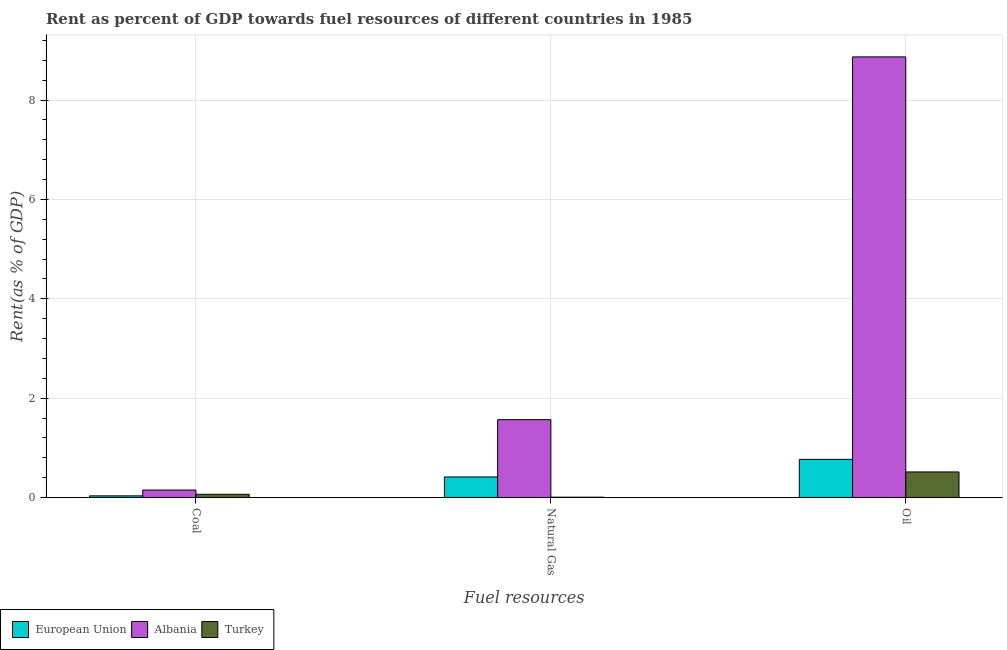How many groups of bars are there?
Offer a very short reply. 3. Are the number of bars per tick equal to the number of legend labels?
Your response must be concise. Yes. Are the number of bars on each tick of the X-axis equal?
Offer a very short reply. Yes. How many bars are there on the 3rd tick from the left?
Give a very brief answer. 3. What is the label of the 3rd group of bars from the left?
Provide a short and direct response. Oil. What is the rent towards coal in Albania?
Keep it short and to the point. 0.15. Across all countries, what is the maximum rent towards coal?
Your answer should be very brief. 0.15. Across all countries, what is the minimum rent towards oil?
Offer a terse response. 0.51. In which country was the rent towards natural gas maximum?
Offer a terse response. Albania. In which country was the rent towards natural gas minimum?
Your answer should be very brief. Turkey. What is the total rent towards natural gas in the graph?
Offer a terse response. 1.99. What is the difference between the rent towards oil in Albania and that in Turkey?
Give a very brief answer. 8.35. What is the difference between the rent towards natural gas in Albania and the rent towards oil in European Union?
Provide a succinct answer. 0.8. What is the average rent towards coal per country?
Offer a terse response. 0.08. What is the difference between the rent towards coal and rent towards oil in Turkey?
Provide a succinct answer. -0.45. In how many countries, is the rent towards coal greater than 8.4 %?
Offer a terse response. 0. What is the ratio of the rent towards oil in Albania to that in Turkey?
Your answer should be compact. 17.25. What is the difference between the highest and the second highest rent towards oil?
Offer a terse response. 8.1. What is the difference between the highest and the lowest rent towards oil?
Provide a succinct answer. 8.35. In how many countries, is the rent towards coal greater than the average rent towards coal taken over all countries?
Your answer should be compact. 1. What does the 1st bar from the left in Coal represents?
Your response must be concise. European Union. Is it the case that in every country, the sum of the rent towards coal and rent towards natural gas is greater than the rent towards oil?
Give a very brief answer. No. How many bars are there?
Provide a short and direct response. 9. Are all the bars in the graph horizontal?
Your answer should be very brief. No. Does the graph contain any zero values?
Provide a short and direct response. No. Does the graph contain grids?
Your response must be concise. Yes. Where does the legend appear in the graph?
Keep it short and to the point. Bottom left. How are the legend labels stacked?
Your answer should be very brief. Horizontal. What is the title of the graph?
Make the answer very short. Rent as percent of GDP towards fuel resources of different countries in 1985. Does "Congo (Republic)" appear as one of the legend labels in the graph?
Ensure brevity in your answer.  No. What is the label or title of the X-axis?
Make the answer very short. Fuel resources. What is the label or title of the Y-axis?
Give a very brief answer. Rent(as % of GDP). What is the Rent(as % of GDP) of European Union in Coal?
Keep it short and to the point. 0.03. What is the Rent(as % of GDP) in Albania in Coal?
Your answer should be compact. 0.15. What is the Rent(as % of GDP) of Turkey in Coal?
Your response must be concise. 0.06. What is the Rent(as % of GDP) of European Union in Natural Gas?
Your response must be concise. 0.41. What is the Rent(as % of GDP) of Albania in Natural Gas?
Your response must be concise. 1.57. What is the Rent(as % of GDP) in Turkey in Natural Gas?
Keep it short and to the point. 0.01. What is the Rent(as % of GDP) of European Union in Oil?
Offer a very short reply. 0.77. What is the Rent(as % of GDP) in Albania in Oil?
Your answer should be compact. 8.87. What is the Rent(as % of GDP) of Turkey in Oil?
Provide a short and direct response. 0.51. Across all Fuel resources, what is the maximum Rent(as % of GDP) in European Union?
Your answer should be compact. 0.77. Across all Fuel resources, what is the maximum Rent(as % of GDP) in Albania?
Provide a succinct answer. 8.87. Across all Fuel resources, what is the maximum Rent(as % of GDP) in Turkey?
Provide a short and direct response. 0.51. Across all Fuel resources, what is the minimum Rent(as % of GDP) of European Union?
Your response must be concise. 0.03. Across all Fuel resources, what is the minimum Rent(as % of GDP) in Albania?
Your response must be concise. 0.15. Across all Fuel resources, what is the minimum Rent(as % of GDP) of Turkey?
Ensure brevity in your answer.  0.01. What is the total Rent(as % of GDP) of European Union in the graph?
Your answer should be compact. 1.21. What is the total Rent(as % of GDP) of Albania in the graph?
Offer a very short reply. 10.59. What is the total Rent(as % of GDP) of Turkey in the graph?
Give a very brief answer. 0.59. What is the difference between the Rent(as % of GDP) in European Union in Coal and that in Natural Gas?
Provide a short and direct response. -0.38. What is the difference between the Rent(as % of GDP) of Albania in Coal and that in Natural Gas?
Offer a terse response. -1.42. What is the difference between the Rent(as % of GDP) of Turkey in Coal and that in Natural Gas?
Offer a very short reply. 0.06. What is the difference between the Rent(as % of GDP) in European Union in Coal and that in Oil?
Your answer should be compact. -0.73. What is the difference between the Rent(as % of GDP) in Albania in Coal and that in Oil?
Provide a short and direct response. -8.72. What is the difference between the Rent(as % of GDP) in Turkey in Coal and that in Oil?
Your response must be concise. -0.45. What is the difference between the Rent(as % of GDP) in European Union in Natural Gas and that in Oil?
Make the answer very short. -0.35. What is the difference between the Rent(as % of GDP) in Albania in Natural Gas and that in Oil?
Your answer should be compact. -7.3. What is the difference between the Rent(as % of GDP) of Turkey in Natural Gas and that in Oil?
Offer a terse response. -0.51. What is the difference between the Rent(as % of GDP) in European Union in Coal and the Rent(as % of GDP) in Albania in Natural Gas?
Your answer should be compact. -1.53. What is the difference between the Rent(as % of GDP) in European Union in Coal and the Rent(as % of GDP) in Turkey in Natural Gas?
Your answer should be very brief. 0.03. What is the difference between the Rent(as % of GDP) in Albania in Coal and the Rent(as % of GDP) in Turkey in Natural Gas?
Keep it short and to the point. 0.14. What is the difference between the Rent(as % of GDP) of European Union in Coal and the Rent(as % of GDP) of Albania in Oil?
Provide a succinct answer. -8.84. What is the difference between the Rent(as % of GDP) in European Union in Coal and the Rent(as % of GDP) in Turkey in Oil?
Ensure brevity in your answer.  -0.48. What is the difference between the Rent(as % of GDP) of Albania in Coal and the Rent(as % of GDP) of Turkey in Oil?
Give a very brief answer. -0.36. What is the difference between the Rent(as % of GDP) in European Union in Natural Gas and the Rent(as % of GDP) in Albania in Oil?
Ensure brevity in your answer.  -8.46. What is the difference between the Rent(as % of GDP) of European Union in Natural Gas and the Rent(as % of GDP) of Turkey in Oil?
Ensure brevity in your answer.  -0.1. What is the difference between the Rent(as % of GDP) of Albania in Natural Gas and the Rent(as % of GDP) of Turkey in Oil?
Your answer should be very brief. 1.05. What is the average Rent(as % of GDP) of European Union per Fuel resources?
Give a very brief answer. 0.4. What is the average Rent(as % of GDP) of Albania per Fuel resources?
Your answer should be very brief. 3.53. What is the average Rent(as % of GDP) in Turkey per Fuel resources?
Keep it short and to the point. 0.2. What is the difference between the Rent(as % of GDP) in European Union and Rent(as % of GDP) in Albania in Coal?
Keep it short and to the point. -0.12. What is the difference between the Rent(as % of GDP) in European Union and Rent(as % of GDP) in Turkey in Coal?
Keep it short and to the point. -0.03. What is the difference between the Rent(as % of GDP) of Albania and Rent(as % of GDP) of Turkey in Coal?
Provide a short and direct response. 0.09. What is the difference between the Rent(as % of GDP) in European Union and Rent(as % of GDP) in Albania in Natural Gas?
Your response must be concise. -1.15. What is the difference between the Rent(as % of GDP) in European Union and Rent(as % of GDP) in Turkey in Natural Gas?
Keep it short and to the point. 0.41. What is the difference between the Rent(as % of GDP) in Albania and Rent(as % of GDP) in Turkey in Natural Gas?
Your answer should be compact. 1.56. What is the difference between the Rent(as % of GDP) in European Union and Rent(as % of GDP) in Albania in Oil?
Provide a succinct answer. -8.1. What is the difference between the Rent(as % of GDP) of European Union and Rent(as % of GDP) of Turkey in Oil?
Offer a very short reply. 0.25. What is the difference between the Rent(as % of GDP) in Albania and Rent(as % of GDP) in Turkey in Oil?
Ensure brevity in your answer.  8.35. What is the ratio of the Rent(as % of GDP) in European Union in Coal to that in Natural Gas?
Your answer should be compact. 0.08. What is the ratio of the Rent(as % of GDP) of Albania in Coal to that in Natural Gas?
Offer a very short reply. 0.1. What is the ratio of the Rent(as % of GDP) of Turkey in Coal to that in Natural Gas?
Offer a very short reply. 9.88. What is the ratio of the Rent(as % of GDP) of European Union in Coal to that in Oil?
Give a very brief answer. 0.04. What is the ratio of the Rent(as % of GDP) of Albania in Coal to that in Oil?
Provide a short and direct response. 0.02. What is the ratio of the Rent(as % of GDP) in Turkey in Coal to that in Oil?
Your answer should be very brief. 0.13. What is the ratio of the Rent(as % of GDP) of European Union in Natural Gas to that in Oil?
Offer a terse response. 0.54. What is the ratio of the Rent(as % of GDP) in Albania in Natural Gas to that in Oil?
Offer a very short reply. 0.18. What is the ratio of the Rent(as % of GDP) in Turkey in Natural Gas to that in Oil?
Provide a short and direct response. 0.01. What is the difference between the highest and the second highest Rent(as % of GDP) in European Union?
Provide a succinct answer. 0.35. What is the difference between the highest and the second highest Rent(as % of GDP) of Albania?
Your answer should be very brief. 7.3. What is the difference between the highest and the second highest Rent(as % of GDP) in Turkey?
Offer a very short reply. 0.45. What is the difference between the highest and the lowest Rent(as % of GDP) of European Union?
Make the answer very short. 0.73. What is the difference between the highest and the lowest Rent(as % of GDP) of Albania?
Provide a succinct answer. 8.72. What is the difference between the highest and the lowest Rent(as % of GDP) in Turkey?
Keep it short and to the point. 0.51. 